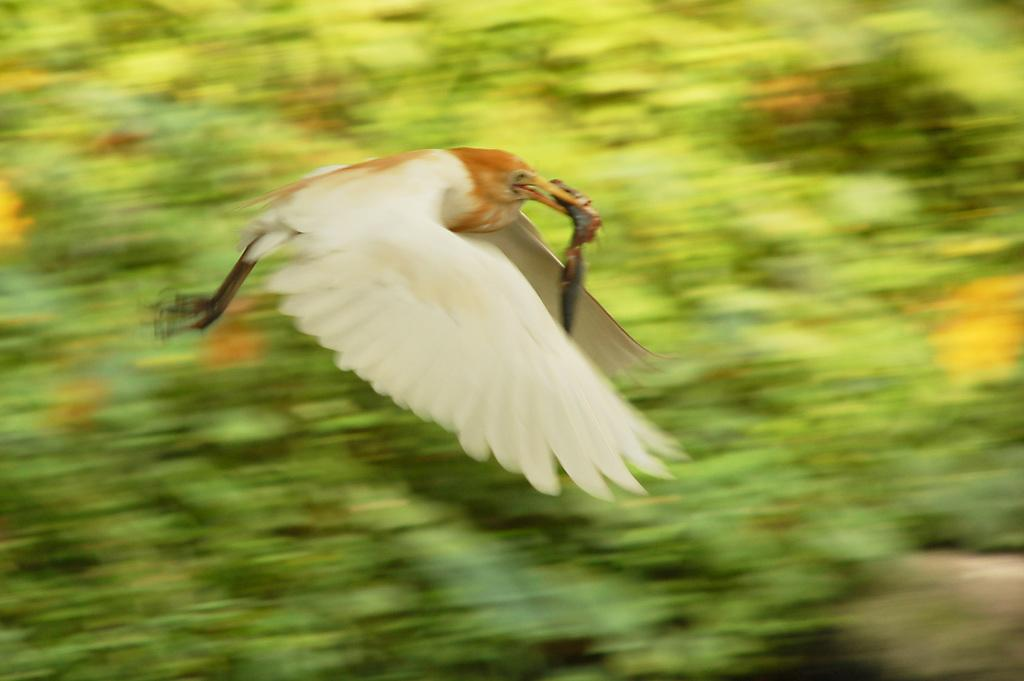What type of animal is present in the image? There is a bird in the image. What is the color of the bird? The bird is white in color. What is the bird doing in the image? The bird is flying. What is the bird holding in its mouth? The bird is holding something in its mouth. What can be seen in the background of the image? There are trees visible in the background of the image. What caption would best describe the boys and the man in the image? There are no boys or man present in the image; it only features a white bird flying and holding something in its mouth. 